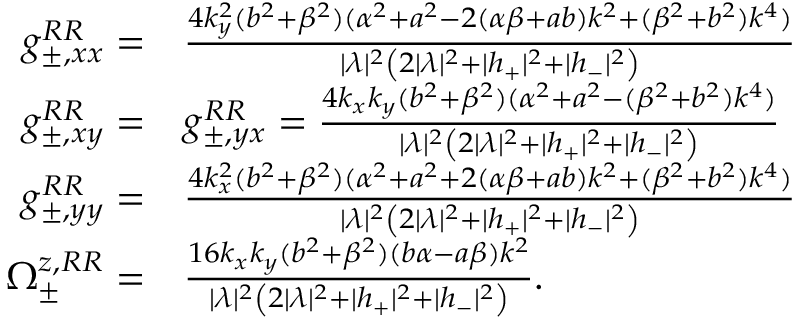Convert formula to latex. <formula><loc_0><loc_0><loc_500><loc_500>\begin{array} { r l } { g _ { \pm , x x } ^ { R R } = } & { \frac { 4 k _ { y } ^ { 2 } ( b ^ { 2 } + \beta ^ { 2 } ) ( \alpha ^ { 2 } + a ^ { 2 } - 2 ( \alpha \beta + a b ) k ^ { 2 } + ( \beta ^ { 2 } + b ^ { 2 } ) k ^ { 4 } ) } { | \lambda | ^ { 2 } \left ( 2 | \lambda | ^ { 2 } + | h _ { + } | ^ { 2 } + | h _ { - } | ^ { 2 } \right ) } } \\ { g _ { \pm , x y } ^ { R R } = } & { g _ { \pm , y x } ^ { R R } = \frac { 4 k _ { x } k _ { y } ( b ^ { 2 } + \beta ^ { 2 } ) ( \alpha ^ { 2 } + a ^ { 2 } - ( \beta ^ { 2 } + b ^ { 2 } ) k ^ { 4 } ) } { | \lambda | ^ { 2 } \left ( 2 | \lambda | ^ { 2 } + | h _ { + } | ^ { 2 } + | h _ { - } | ^ { 2 } \right ) } } \\ { g _ { \pm , y y } ^ { R R } = } & { \frac { 4 k _ { x } ^ { 2 } ( b ^ { 2 } + \beta ^ { 2 } ) ( \alpha ^ { 2 } + a ^ { 2 } + 2 ( \alpha \beta + a b ) k ^ { 2 } + ( \beta ^ { 2 } + b ^ { 2 } ) k ^ { 4 } ) } { | \lambda | ^ { 2 } \left ( 2 | \lambda | ^ { 2 } + | h _ { + } | ^ { 2 } + | h _ { - } | ^ { 2 } \right ) } } \\ { \Omega _ { \pm } ^ { z , R R } = } & { \frac { 1 6 k _ { x } k _ { y } ( b ^ { 2 } + \beta ^ { 2 } ) ( b \alpha - a \beta ) k ^ { 2 } } { | \lambda | ^ { 2 } \left ( 2 | \lambda | ^ { 2 } + | h _ { + } | ^ { 2 } + | h _ { - } | ^ { 2 } \right ) } . } \end{array}</formula> 